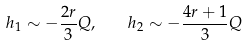Convert formula to latex. <formula><loc_0><loc_0><loc_500><loc_500>h _ { 1 } \sim - \frac { 2 r } { 3 } Q , \quad h _ { 2 } \sim - \frac { 4 r + 1 } { 3 } Q</formula> 